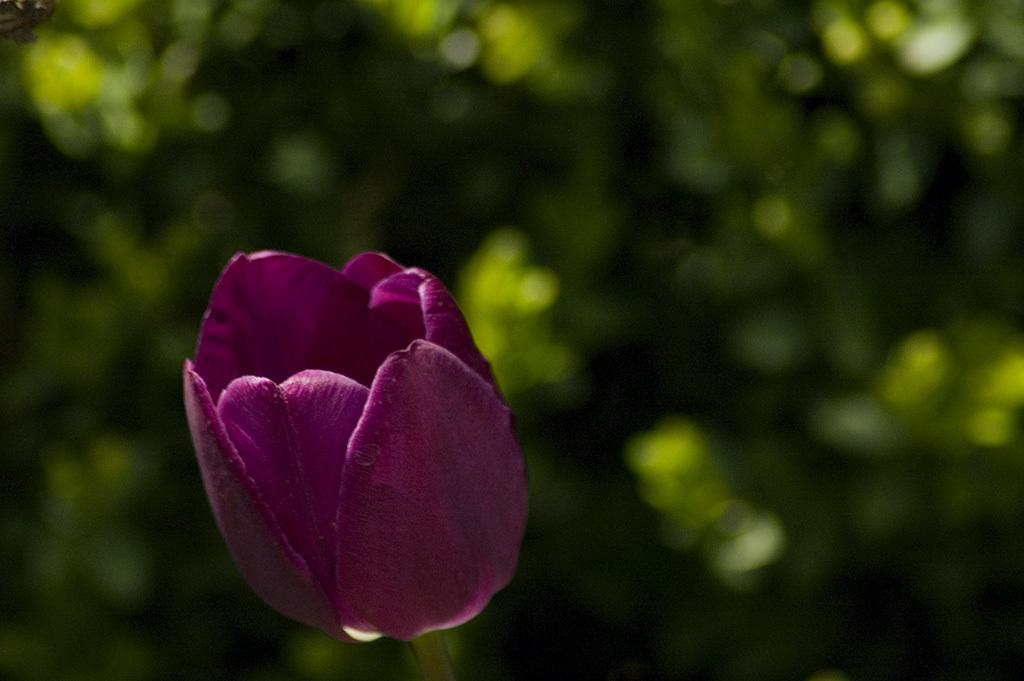What is the main subject of the image? There is a flower in the image. Can you describe the background of the image? There are plants in the background of the image. How many rabbits are sitting on the egg in the image? There are no rabbits or eggs present in the image; it only features a flower and plants in the background. 